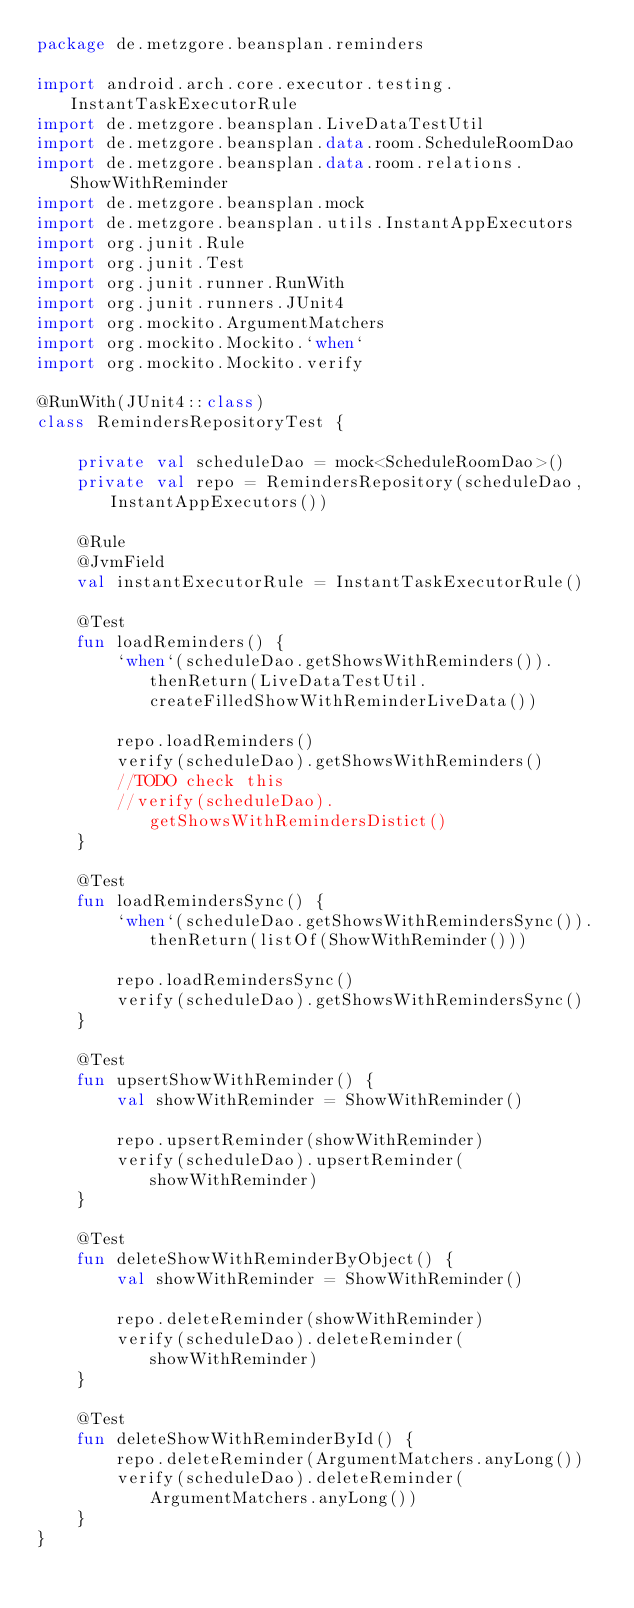<code> <loc_0><loc_0><loc_500><loc_500><_Kotlin_>package de.metzgore.beansplan.reminders

import android.arch.core.executor.testing.InstantTaskExecutorRule
import de.metzgore.beansplan.LiveDataTestUtil
import de.metzgore.beansplan.data.room.ScheduleRoomDao
import de.metzgore.beansplan.data.room.relations.ShowWithReminder
import de.metzgore.beansplan.mock
import de.metzgore.beansplan.utils.InstantAppExecutors
import org.junit.Rule
import org.junit.Test
import org.junit.runner.RunWith
import org.junit.runners.JUnit4
import org.mockito.ArgumentMatchers
import org.mockito.Mockito.`when`
import org.mockito.Mockito.verify

@RunWith(JUnit4::class)
class RemindersRepositoryTest {

    private val scheduleDao = mock<ScheduleRoomDao>()
    private val repo = RemindersRepository(scheduleDao, InstantAppExecutors())

    @Rule
    @JvmField
    val instantExecutorRule = InstantTaskExecutorRule()

    @Test
    fun loadReminders() {
        `when`(scheduleDao.getShowsWithReminders()).thenReturn(LiveDataTestUtil.createFilledShowWithReminderLiveData())

        repo.loadReminders()
        verify(scheduleDao).getShowsWithReminders()
        //TODO check this
        //verify(scheduleDao).getShowsWithRemindersDistict()
    }

    @Test
    fun loadRemindersSync() {
        `when`(scheduleDao.getShowsWithRemindersSync()).thenReturn(listOf(ShowWithReminder()))

        repo.loadRemindersSync()
        verify(scheduleDao).getShowsWithRemindersSync()
    }

    @Test
    fun upsertShowWithReminder() {
        val showWithReminder = ShowWithReminder()

        repo.upsertReminder(showWithReminder)
        verify(scheduleDao).upsertReminder(showWithReminder)
    }

    @Test
    fun deleteShowWithReminderByObject() {
        val showWithReminder = ShowWithReminder()

        repo.deleteReminder(showWithReminder)
        verify(scheduleDao).deleteReminder(showWithReminder)
    }

    @Test
    fun deleteShowWithReminderById() {
        repo.deleteReminder(ArgumentMatchers.anyLong())
        verify(scheduleDao).deleteReminder(ArgumentMatchers.anyLong())
    }
}</code> 